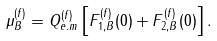<formula> <loc_0><loc_0><loc_500><loc_500>\mu ^ { ( f ) } _ { B } = Q ^ { ( f ) } _ { e . m } \left [ F ^ { ( f ) } _ { 1 , B } ( 0 ) + F ^ { ( f ) } _ { 2 , B } ( 0 ) \right ] .</formula> 